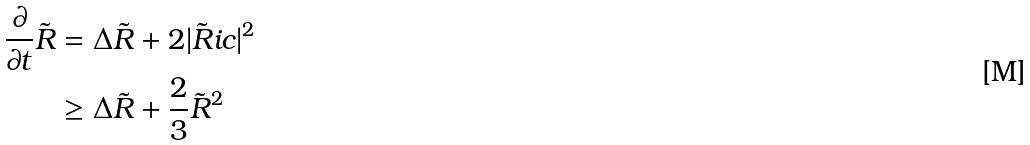Convert formula to latex. <formula><loc_0><loc_0><loc_500><loc_500>\frac { \partial } { \partial t } \tilde { R } & = \Delta \tilde { R } + 2 | \tilde { R } i c | ^ { 2 } \\ & \geq \Delta \tilde { R } + \frac { 2 } { 3 } \tilde { R } ^ { 2 }</formula> 